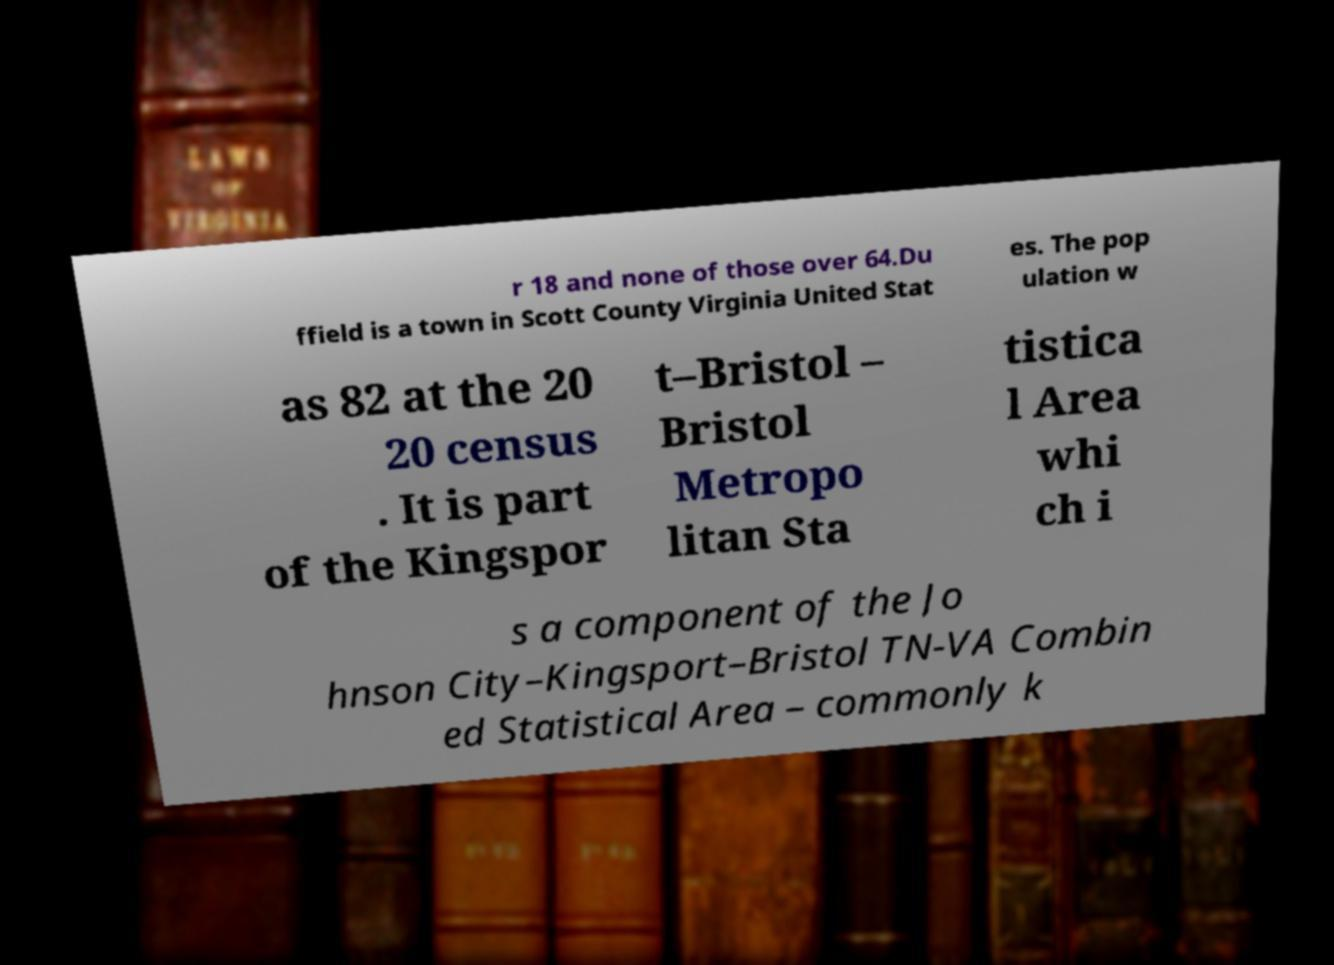Please read and relay the text visible in this image. What does it say? r 18 and none of those over 64.Du ffield is a town in Scott County Virginia United Stat es. The pop ulation w as 82 at the 20 20 census . It is part of the Kingspor t–Bristol – Bristol Metropo litan Sta tistica l Area whi ch i s a component of the Jo hnson City–Kingsport–Bristol TN-VA Combin ed Statistical Area – commonly k 